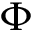<formula> <loc_0><loc_0><loc_500><loc_500>\Phi</formula> 